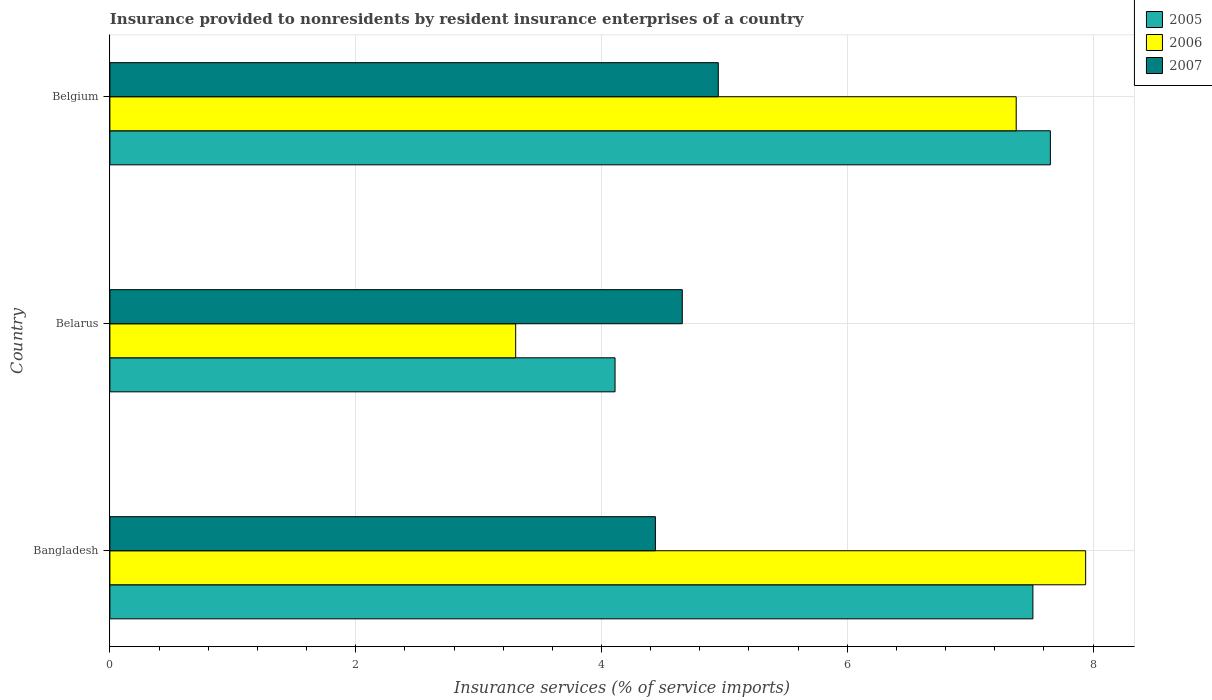How many groups of bars are there?
Give a very brief answer. 3. Are the number of bars per tick equal to the number of legend labels?
Give a very brief answer. Yes. What is the insurance provided to nonresidents in 2007 in Belarus?
Give a very brief answer. 4.66. Across all countries, what is the maximum insurance provided to nonresidents in 2006?
Your response must be concise. 7.94. Across all countries, what is the minimum insurance provided to nonresidents in 2007?
Provide a succinct answer. 4.44. In which country was the insurance provided to nonresidents in 2006 maximum?
Make the answer very short. Bangladesh. In which country was the insurance provided to nonresidents in 2005 minimum?
Ensure brevity in your answer.  Belarus. What is the total insurance provided to nonresidents in 2007 in the graph?
Give a very brief answer. 14.05. What is the difference between the insurance provided to nonresidents in 2005 in Belarus and that in Belgium?
Your answer should be compact. -3.54. What is the difference between the insurance provided to nonresidents in 2007 in Bangladesh and the insurance provided to nonresidents in 2006 in Belgium?
Ensure brevity in your answer.  -2.94. What is the average insurance provided to nonresidents in 2006 per country?
Ensure brevity in your answer.  6.21. What is the difference between the insurance provided to nonresidents in 2007 and insurance provided to nonresidents in 2005 in Belgium?
Provide a short and direct response. -2.7. In how many countries, is the insurance provided to nonresidents in 2005 greater than 7.2 %?
Your answer should be very brief. 2. What is the ratio of the insurance provided to nonresidents in 2007 in Bangladesh to that in Belgium?
Ensure brevity in your answer.  0.9. Is the insurance provided to nonresidents in 2007 in Bangladesh less than that in Belarus?
Your response must be concise. Yes. What is the difference between the highest and the second highest insurance provided to nonresidents in 2005?
Ensure brevity in your answer.  0.14. What is the difference between the highest and the lowest insurance provided to nonresidents in 2005?
Provide a succinct answer. 3.54. In how many countries, is the insurance provided to nonresidents in 2007 greater than the average insurance provided to nonresidents in 2007 taken over all countries?
Offer a very short reply. 1. Is it the case that in every country, the sum of the insurance provided to nonresidents in 2005 and insurance provided to nonresidents in 2006 is greater than the insurance provided to nonresidents in 2007?
Ensure brevity in your answer.  Yes. How many bars are there?
Make the answer very short. 9. Are all the bars in the graph horizontal?
Provide a succinct answer. Yes. What is the difference between two consecutive major ticks on the X-axis?
Ensure brevity in your answer.  2. Does the graph contain grids?
Your response must be concise. Yes. How are the legend labels stacked?
Your response must be concise. Vertical. What is the title of the graph?
Keep it short and to the point. Insurance provided to nonresidents by resident insurance enterprises of a country. What is the label or title of the X-axis?
Provide a succinct answer. Insurance services (% of service imports). What is the label or title of the Y-axis?
Provide a short and direct response. Country. What is the Insurance services (% of service imports) of 2005 in Bangladesh?
Offer a very short reply. 7.51. What is the Insurance services (% of service imports) in 2006 in Bangladesh?
Keep it short and to the point. 7.94. What is the Insurance services (% of service imports) of 2007 in Bangladesh?
Make the answer very short. 4.44. What is the Insurance services (% of service imports) in 2005 in Belarus?
Your answer should be very brief. 4.11. What is the Insurance services (% of service imports) in 2006 in Belarus?
Provide a succinct answer. 3.3. What is the Insurance services (% of service imports) in 2007 in Belarus?
Keep it short and to the point. 4.66. What is the Insurance services (% of service imports) in 2005 in Belgium?
Provide a short and direct response. 7.65. What is the Insurance services (% of service imports) in 2006 in Belgium?
Offer a very short reply. 7.37. What is the Insurance services (% of service imports) in 2007 in Belgium?
Your answer should be compact. 4.95. Across all countries, what is the maximum Insurance services (% of service imports) in 2005?
Keep it short and to the point. 7.65. Across all countries, what is the maximum Insurance services (% of service imports) of 2006?
Make the answer very short. 7.94. Across all countries, what is the maximum Insurance services (% of service imports) in 2007?
Your answer should be compact. 4.95. Across all countries, what is the minimum Insurance services (% of service imports) of 2005?
Your answer should be very brief. 4.11. Across all countries, what is the minimum Insurance services (% of service imports) of 2006?
Ensure brevity in your answer.  3.3. Across all countries, what is the minimum Insurance services (% of service imports) of 2007?
Your response must be concise. 4.44. What is the total Insurance services (% of service imports) of 2005 in the graph?
Your answer should be very brief. 19.27. What is the total Insurance services (% of service imports) in 2006 in the graph?
Ensure brevity in your answer.  18.62. What is the total Insurance services (% of service imports) of 2007 in the graph?
Your response must be concise. 14.05. What is the difference between the Insurance services (% of service imports) of 2006 in Bangladesh and that in Belarus?
Make the answer very short. 4.64. What is the difference between the Insurance services (% of service imports) of 2007 in Bangladesh and that in Belarus?
Offer a very short reply. -0.22. What is the difference between the Insurance services (% of service imports) of 2005 in Bangladesh and that in Belgium?
Keep it short and to the point. -0.14. What is the difference between the Insurance services (% of service imports) in 2006 in Bangladesh and that in Belgium?
Provide a short and direct response. 0.57. What is the difference between the Insurance services (% of service imports) of 2007 in Bangladesh and that in Belgium?
Your answer should be compact. -0.51. What is the difference between the Insurance services (% of service imports) in 2005 in Belarus and that in Belgium?
Your answer should be compact. -3.54. What is the difference between the Insurance services (% of service imports) in 2006 in Belarus and that in Belgium?
Ensure brevity in your answer.  -4.07. What is the difference between the Insurance services (% of service imports) of 2007 in Belarus and that in Belgium?
Your answer should be compact. -0.29. What is the difference between the Insurance services (% of service imports) of 2005 in Bangladesh and the Insurance services (% of service imports) of 2006 in Belarus?
Provide a short and direct response. 4.21. What is the difference between the Insurance services (% of service imports) of 2005 in Bangladesh and the Insurance services (% of service imports) of 2007 in Belarus?
Offer a terse response. 2.85. What is the difference between the Insurance services (% of service imports) in 2006 in Bangladesh and the Insurance services (% of service imports) in 2007 in Belarus?
Ensure brevity in your answer.  3.28. What is the difference between the Insurance services (% of service imports) in 2005 in Bangladesh and the Insurance services (% of service imports) in 2006 in Belgium?
Your answer should be very brief. 0.14. What is the difference between the Insurance services (% of service imports) of 2005 in Bangladesh and the Insurance services (% of service imports) of 2007 in Belgium?
Your answer should be very brief. 2.56. What is the difference between the Insurance services (% of service imports) in 2006 in Bangladesh and the Insurance services (% of service imports) in 2007 in Belgium?
Make the answer very short. 2.99. What is the difference between the Insurance services (% of service imports) of 2005 in Belarus and the Insurance services (% of service imports) of 2006 in Belgium?
Your answer should be compact. -3.26. What is the difference between the Insurance services (% of service imports) in 2005 in Belarus and the Insurance services (% of service imports) in 2007 in Belgium?
Keep it short and to the point. -0.84. What is the difference between the Insurance services (% of service imports) of 2006 in Belarus and the Insurance services (% of service imports) of 2007 in Belgium?
Your answer should be compact. -1.65. What is the average Insurance services (% of service imports) of 2005 per country?
Provide a short and direct response. 6.42. What is the average Insurance services (% of service imports) in 2006 per country?
Provide a succinct answer. 6.21. What is the average Insurance services (% of service imports) of 2007 per country?
Your answer should be compact. 4.68. What is the difference between the Insurance services (% of service imports) in 2005 and Insurance services (% of service imports) in 2006 in Bangladesh?
Keep it short and to the point. -0.43. What is the difference between the Insurance services (% of service imports) in 2005 and Insurance services (% of service imports) in 2007 in Bangladesh?
Provide a succinct answer. 3.07. What is the difference between the Insurance services (% of service imports) of 2006 and Insurance services (% of service imports) of 2007 in Bangladesh?
Make the answer very short. 3.5. What is the difference between the Insurance services (% of service imports) of 2005 and Insurance services (% of service imports) of 2006 in Belarus?
Your response must be concise. 0.81. What is the difference between the Insurance services (% of service imports) of 2005 and Insurance services (% of service imports) of 2007 in Belarus?
Provide a succinct answer. -0.55. What is the difference between the Insurance services (% of service imports) in 2006 and Insurance services (% of service imports) in 2007 in Belarus?
Ensure brevity in your answer.  -1.36. What is the difference between the Insurance services (% of service imports) of 2005 and Insurance services (% of service imports) of 2006 in Belgium?
Ensure brevity in your answer.  0.28. What is the difference between the Insurance services (% of service imports) in 2005 and Insurance services (% of service imports) in 2007 in Belgium?
Give a very brief answer. 2.7. What is the difference between the Insurance services (% of service imports) in 2006 and Insurance services (% of service imports) in 2007 in Belgium?
Offer a terse response. 2.42. What is the ratio of the Insurance services (% of service imports) in 2005 in Bangladesh to that in Belarus?
Offer a very short reply. 1.83. What is the ratio of the Insurance services (% of service imports) of 2006 in Bangladesh to that in Belarus?
Give a very brief answer. 2.4. What is the ratio of the Insurance services (% of service imports) of 2007 in Bangladesh to that in Belarus?
Your answer should be very brief. 0.95. What is the ratio of the Insurance services (% of service imports) in 2005 in Bangladesh to that in Belgium?
Keep it short and to the point. 0.98. What is the ratio of the Insurance services (% of service imports) of 2006 in Bangladesh to that in Belgium?
Ensure brevity in your answer.  1.08. What is the ratio of the Insurance services (% of service imports) in 2007 in Bangladesh to that in Belgium?
Your answer should be very brief. 0.9. What is the ratio of the Insurance services (% of service imports) in 2005 in Belarus to that in Belgium?
Your answer should be very brief. 0.54. What is the ratio of the Insurance services (% of service imports) in 2006 in Belarus to that in Belgium?
Give a very brief answer. 0.45. What is the ratio of the Insurance services (% of service imports) in 2007 in Belarus to that in Belgium?
Give a very brief answer. 0.94. What is the difference between the highest and the second highest Insurance services (% of service imports) of 2005?
Make the answer very short. 0.14. What is the difference between the highest and the second highest Insurance services (% of service imports) in 2006?
Make the answer very short. 0.57. What is the difference between the highest and the second highest Insurance services (% of service imports) in 2007?
Offer a terse response. 0.29. What is the difference between the highest and the lowest Insurance services (% of service imports) in 2005?
Your answer should be very brief. 3.54. What is the difference between the highest and the lowest Insurance services (% of service imports) of 2006?
Give a very brief answer. 4.64. What is the difference between the highest and the lowest Insurance services (% of service imports) of 2007?
Keep it short and to the point. 0.51. 